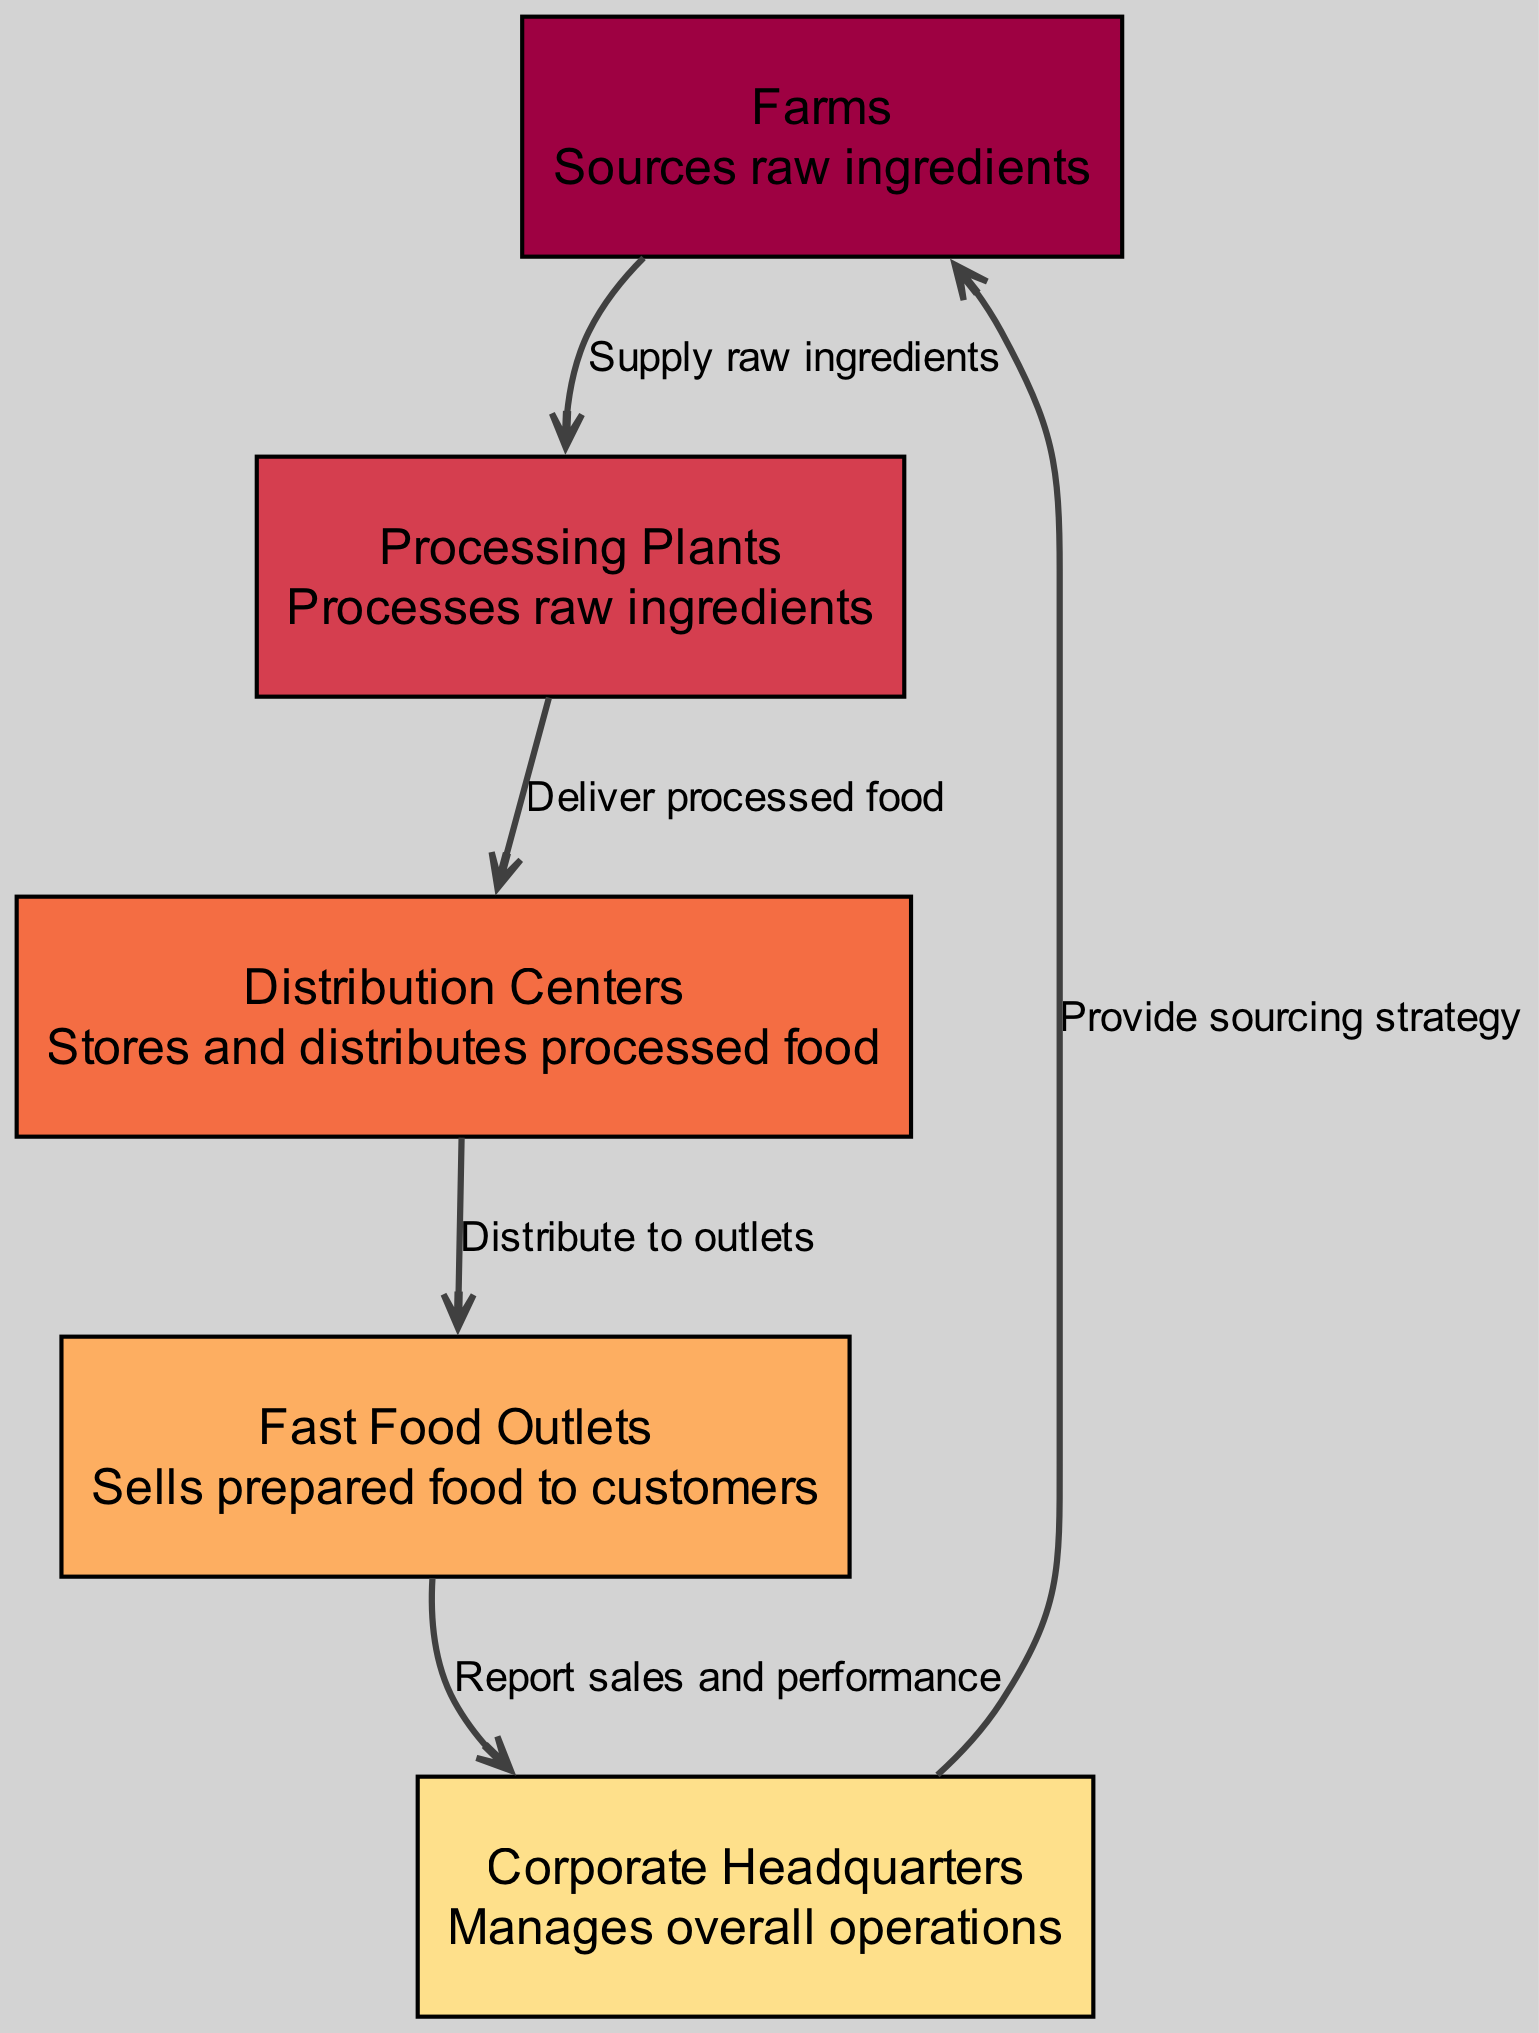What are the nodes in the diagram? The nodes in the diagram are Farms, Processing Plants, Distribution Centers, Fast Food Outlets, and Corporate Headquarters. Each of these represents a different stage in the vertical integration process.
Answer: Farms, Processing Plants, Distribution Centers, Fast Food Outlets, and Corporate Headquarters How many edges are there in the diagram? The diagram has four edges, each representing a connection or flow of materials and information between the nodes.
Answer: Four What does the edge from Farms to Processing Plants represent? It represents the supply of raw ingredients from Farms to Processing Plants. This is the first step of the food chain process where raw materials are sourced.
Answer: Supply raw ingredients Which node reports sales and performance? The node that reports sales and performance is the Fast Food Outlets. This indicates that performance tracking occurs at the retail level where customers interact with the product.
Answer: Fast Food Outlets What is the role of Corporate Headquarters in this diagram? The Corporate Headquarters manages overall operations, linking back to the Farms to provide sourcing strategy, thus playing a pivotal role in the entire supply chain management.
Answer: Manages overall operations If the Processing Plants are unable to deliver processed food, what impact does it have? If Processing Plants cannot deliver processed food, then the Distribution Centers cannot receive any products to store and distribute, ultimately affecting the sales at Fast Food Outlets as they would run out of food to serve customers.
Answer: Decrease in sales How does the flow of the diagram begin? The flow begins at the Farms, where raw ingredients are sourced, leading to Processing Plants which further process these ingredients. This initiates the entire supply chain in this vertical integration.
Answer: Farms Where does the Distribution Centers send products after processing? The Distribution Centers distribute processed food to Fast Food Outlets. This is the step where products are made available for sale to customers.
Answer: Fast Food Outlets What is the relationship between Fast Food Outlets and Corporate Headquarters? The relationship is that Fast Food Outlets report sales and performance data back to Corporate Headquarters, allowing central management to make informed decisions based on retail outcomes.
Answer: Report sales and performance 